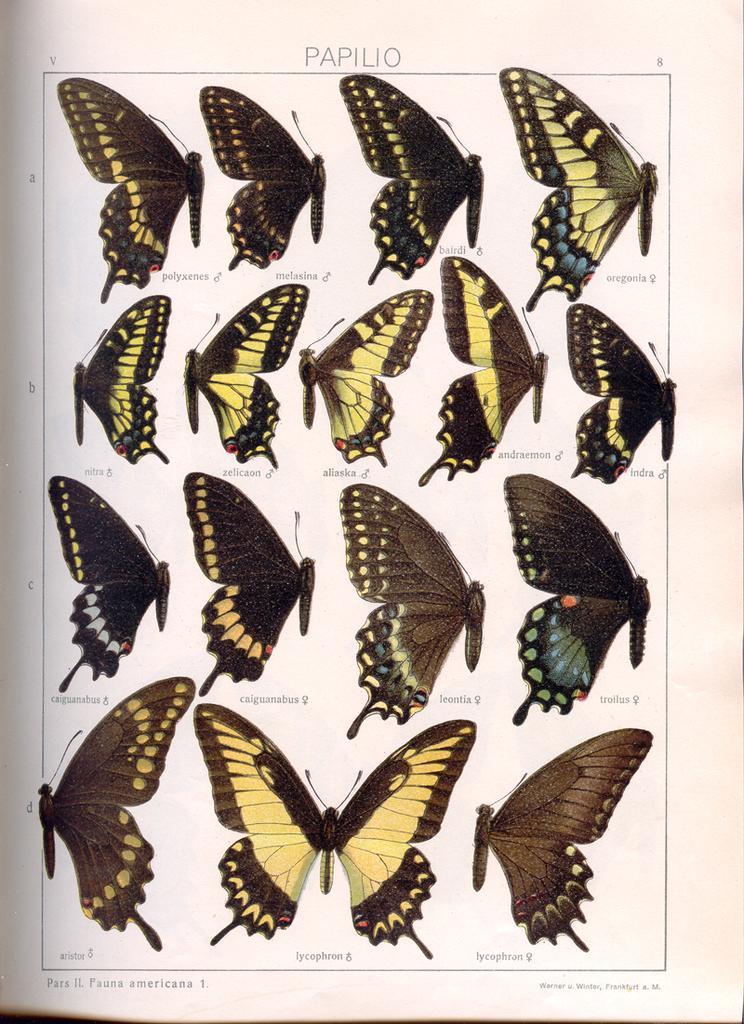What is the main subject of the poster in the image? The main subject of the poster in the image is many butterflies. Are there any other elements on the poster besides the butterflies? Yes, there is text present on the poster. What does the sun taste like in the image? The sun is not present in the image, and therefore it cannot be tasted. 